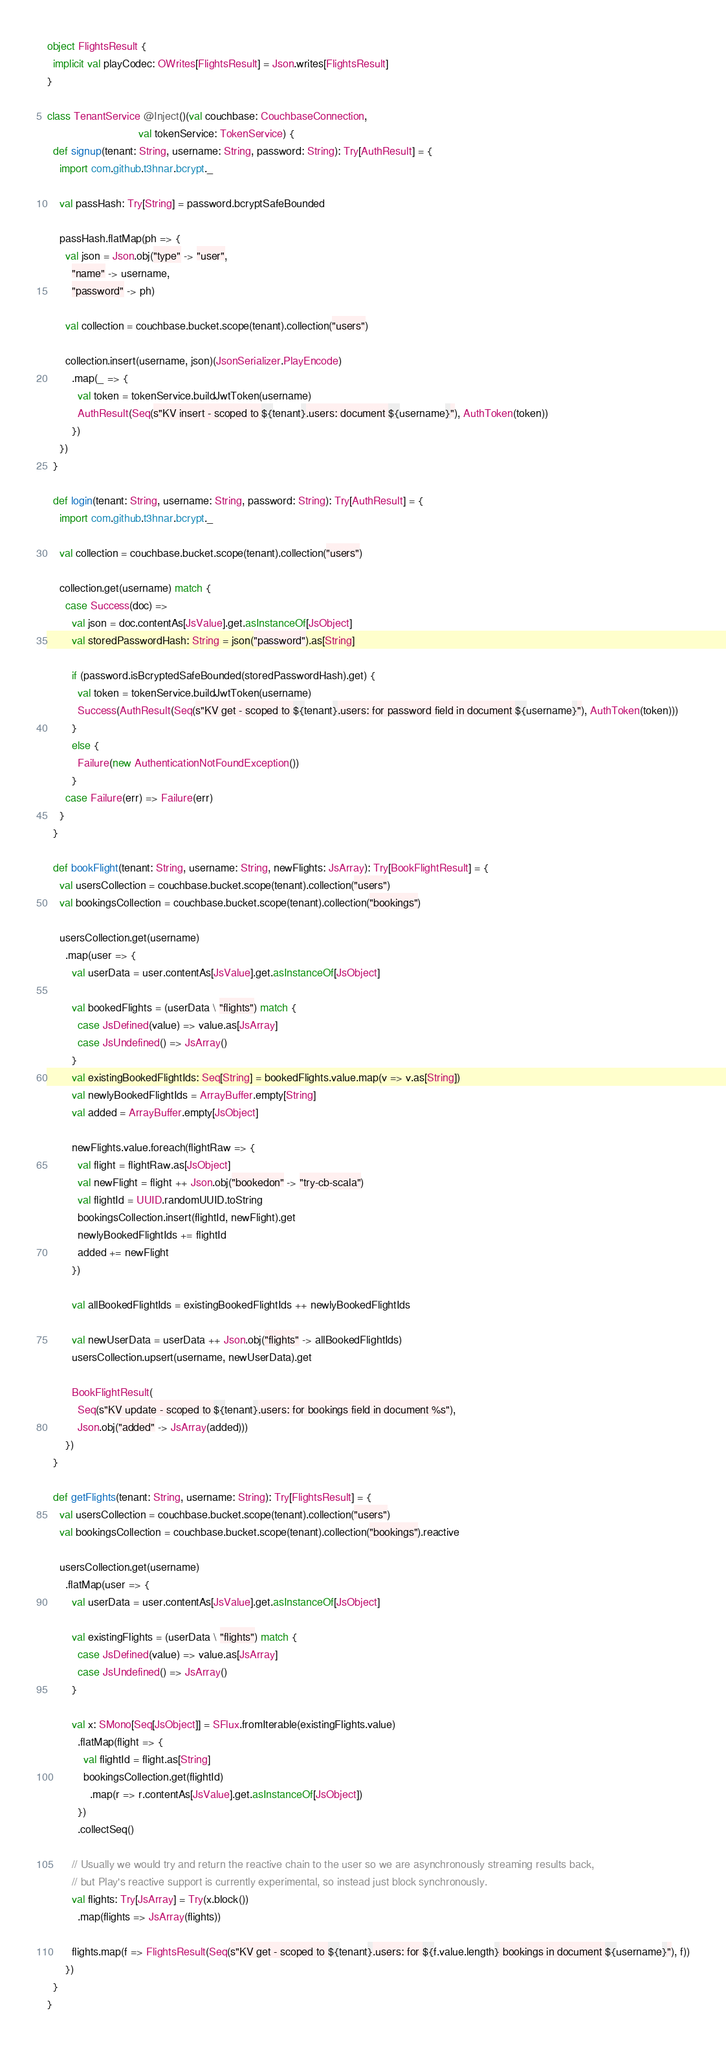<code> <loc_0><loc_0><loc_500><loc_500><_Scala_>
object FlightsResult {
  implicit val playCodec: OWrites[FlightsResult] = Json.writes[FlightsResult]
}

class TenantService @Inject()(val couchbase: CouchbaseConnection,
                              val tokenService: TokenService) {
  def signup(tenant: String, username: String, password: String): Try[AuthResult] = {
    import com.github.t3hnar.bcrypt._

    val passHash: Try[String] = password.bcryptSafeBounded

    passHash.flatMap(ph => {
      val json = Json.obj("type" -> "user",
        "name" -> username,
        "password" -> ph)

      val collection = couchbase.bucket.scope(tenant).collection("users")

      collection.insert(username, json)(JsonSerializer.PlayEncode)
        .map(_ => {
          val token = tokenService.buildJwtToken(username)
          AuthResult(Seq(s"KV insert - scoped to ${tenant}.users: document ${username}"), AuthToken(token))
        })
    })
  }

  def login(tenant: String, username: String, password: String): Try[AuthResult] = {
    import com.github.t3hnar.bcrypt._

    val collection = couchbase.bucket.scope(tenant).collection("users")

    collection.get(username) match {
      case Success(doc) =>
        val json = doc.contentAs[JsValue].get.asInstanceOf[JsObject]
        val storedPasswordHash: String = json("password").as[String]

        if (password.isBcryptedSafeBounded(storedPasswordHash).get) {
          val token = tokenService.buildJwtToken(username)
          Success(AuthResult(Seq(s"KV get - scoped to ${tenant}.users: for password field in document ${username}"), AuthToken(token)))
        }
        else {
          Failure(new AuthenticationNotFoundException())
        }
      case Failure(err) => Failure(err)
    }
  }

  def bookFlight(tenant: String, username: String, newFlights: JsArray): Try[BookFlightResult] = {
    val usersCollection = couchbase.bucket.scope(tenant).collection("users")
    val bookingsCollection = couchbase.bucket.scope(tenant).collection("bookings")

    usersCollection.get(username)
      .map(user => {
        val userData = user.contentAs[JsValue].get.asInstanceOf[JsObject]

        val bookedFlights = (userData \ "flights") match {
          case JsDefined(value) => value.as[JsArray]
          case JsUndefined() => JsArray()
        }
        val existingBookedFlightIds: Seq[String] = bookedFlights.value.map(v => v.as[String])
        val newlyBookedFlightIds = ArrayBuffer.empty[String]
        val added = ArrayBuffer.empty[JsObject]

        newFlights.value.foreach(flightRaw => {
          val flight = flightRaw.as[JsObject]
          val newFlight = flight ++ Json.obj("bookedon" -> "try-cb-scala")
          val flightId = UUID.randomUUID.toString
          bookingsCollection.insert(flightId, newFlight).get
          newlyBookedFlightIds += flightId
          added += newFlight
        })

        val allBookedFlightIds = existingBookedFlightIds ++ newlyBookedFlightIds

        val newUserData = userData ++ Json.obj("flights" -> allBookedFlightIds)
        usersCollection.upsert(username, newUserData).get

        BookFlightResult(
          Seq(s"KV update - scoped to ${tenant}.users: for bookings field in document %s"), 
          Json.obj("added" -> JsArray(added)))
      })
  }

  def getFlights(tenant: String, username: String): Try[FlightsResult] = {
    val usersCollection = couchbase.bucket.scope(tenant).collection("users")
    val bookingsCollection = couchbase.bucket.scope(tenant).collection("bookings").reactive

    usersCollection.get(username)
      .flatMap(user => {
        val userData = user.contentAs[JsValue].get.asInstanceOf[JsObject]

        val existingFlights = (userData \ "flights") match {
          case JsDefined(value) => value.as[JsArray]
          case JsUndefined() => JsArray()
        }

        val x: SMono[Seq[JsObject]] = SFlux.fromIterable(existingFlights.value)
          .flatMap(flight => {
            val flightId = flight.as[String]
            bookingsCollection.get(flightId)
              .map(r => r.contentAs[JsValue].get.asInstanceOf[JsObject])
          })
          .collectSeq()

        // Usually we would try and return the reactive chain to the user so we are asynchronously streaming results back,
        // but Play's reactive support is currently experimental, so instead just block synchronously.
        val flights: Try[JsArray] = Try(x.block())
          .map(flights => JsArray(flights))

        flights.map(f => FlightsResult(Seq(s"KV get - scoped to ${tenant}.users: for ${f.value.length} bookings in document ${username}"), f))
      })
  }
}
</code> 